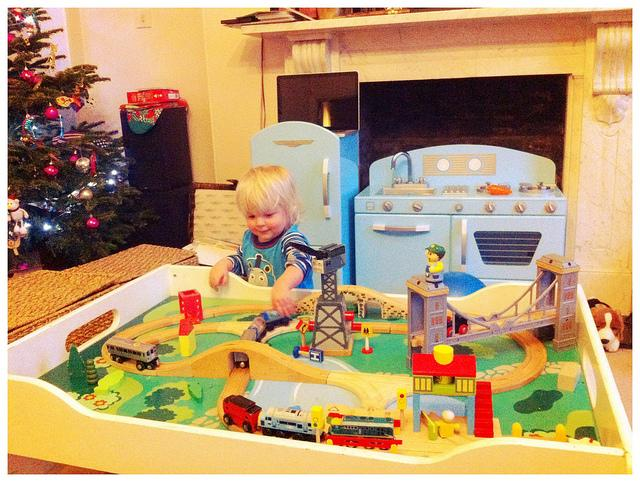What is the child playing with? Please explain your reasoning. train. You are able to see a railroad system with many vehicles on it, there is a locomotive pulling two cars. many modern railroads use electricity instead of coal to power their locomotives. 